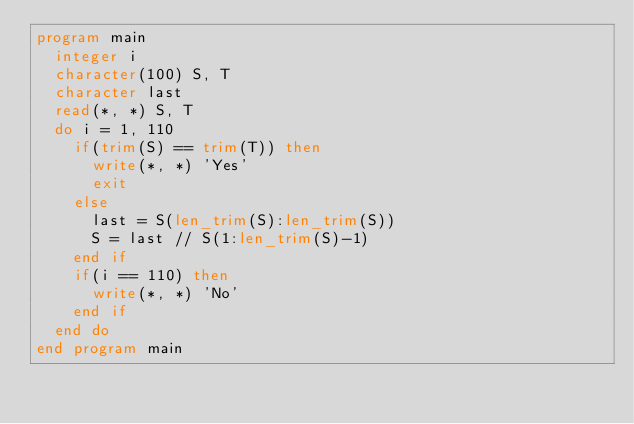Convert code to text. <code><loc_0><loc_0><loc_500><loc_500><_FORTRAN_>program main
	integer i
	character(100) S, T
	character last
	read(*, *) S, T	
	do i = 1, 110
		if(trim(S) == trim(T)) then
			write(*, *) 'Yes'
			exit
		else
			last = S(len_trim(S):len_trim(S))
			S = last // S(1:len_trim(S)-1)
		end if
		if(i == 110) then
			write(*, *) 'No'
		end if
	end do
end program main</code> 